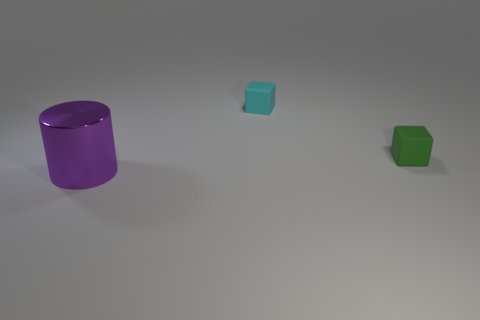Are there any other things that have the same size as the purple cylinder?
Make the answer very short. No. Does the shiny cylinder have the same size as the cyan cube?
Make the answer very short. No. The metal thing has what color?
Make the answer very short. Purple. What number of things are either large purple things or large yellow matte cubes?
Give a very brief answer. 1. Are there any other objects that have the same shape as the small cyan rubber object?
Keep it short and to the point. Yes. What is the shape of the tiny object in front of the small object that is on the left side of the green matte cube?
Provide a short and direct response. Cube. Are there any green matte objects of the same size as the cyan matte cube?
Your answer should be compact. Yes. Are there fewer tiny green rubber blocks than small matte things?
Offer a terse response. Yes. There is a matte object that is on the right side of the small matte object that is behind the small green cube that is in front of the small cyan object; what is its shape?
Provide a succinct answer. Cube. What number of objects are objects behind the shiny cylinder or objects in front of the tiny green matte thing?
Offer a terse response. 3. 